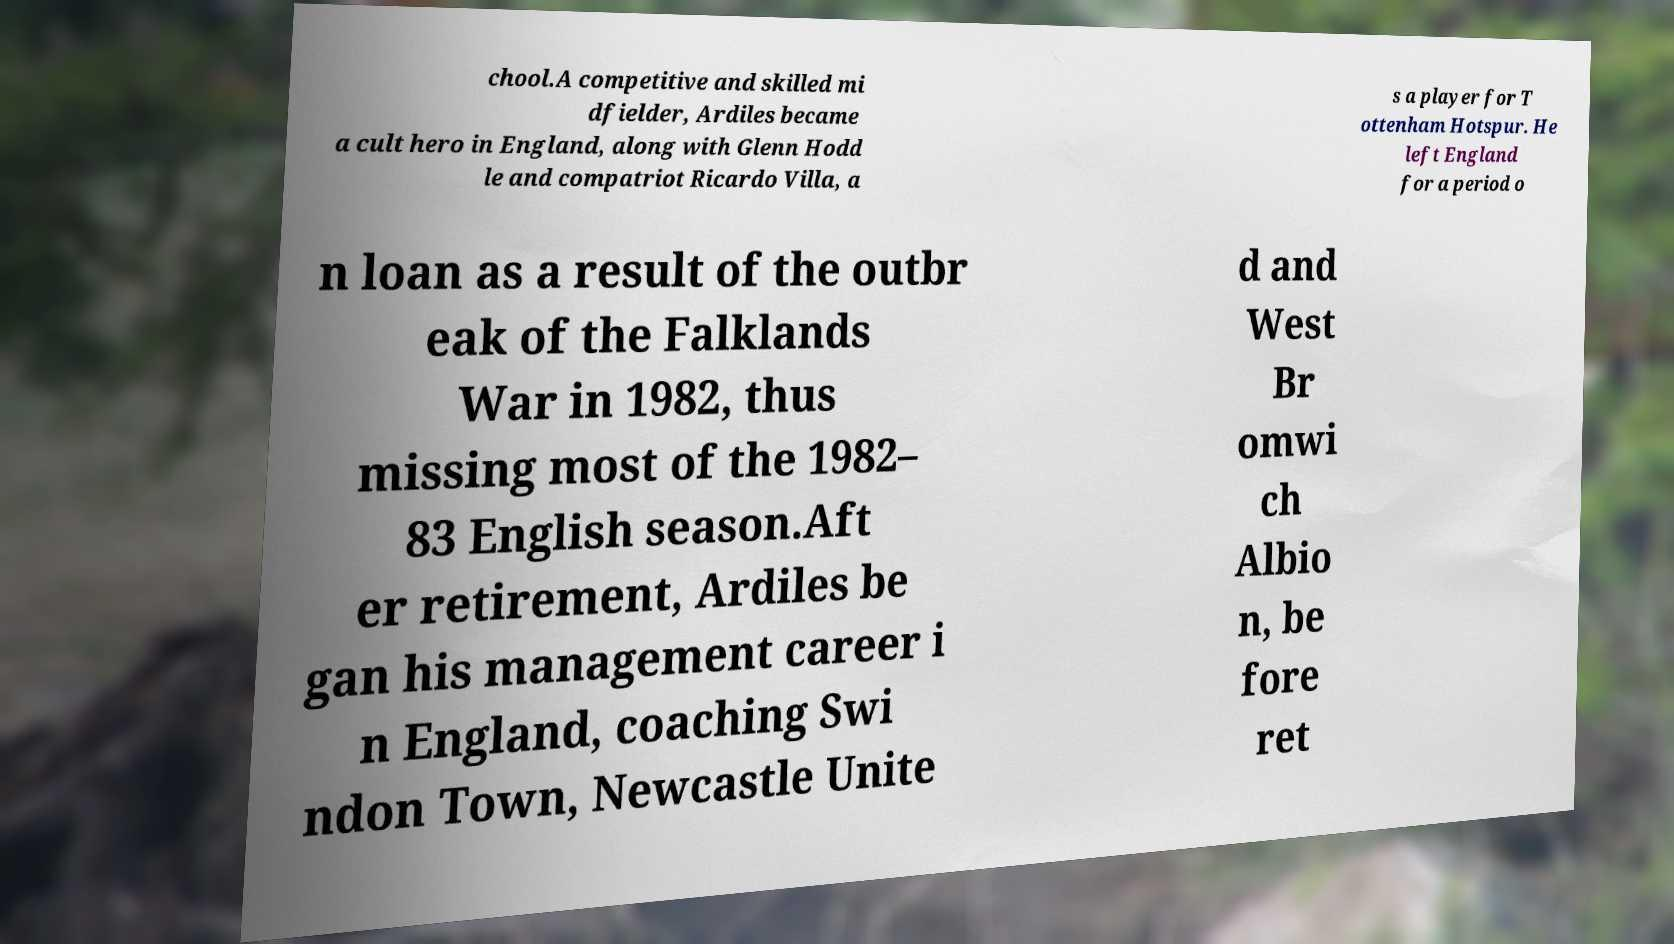Could you extract and type out the text from this image? chool.A competitive and skilled mi dfielder, Ardiles became a cult hero in England, along with Glenn Hodd le and compatriot Ricardo Villa, a s a player for T ottenham Hotspur. He left England for a period o n loan as a result of the outbr eak of the Falklands War in 1982, thus missing most of the 1982– 83 English season.Aft er retirement, Ardiles be gan his management career i n England, coaching Swi ndon Town, Newcastle Unite d and West Br omwi ch Albio n, be fore ret 